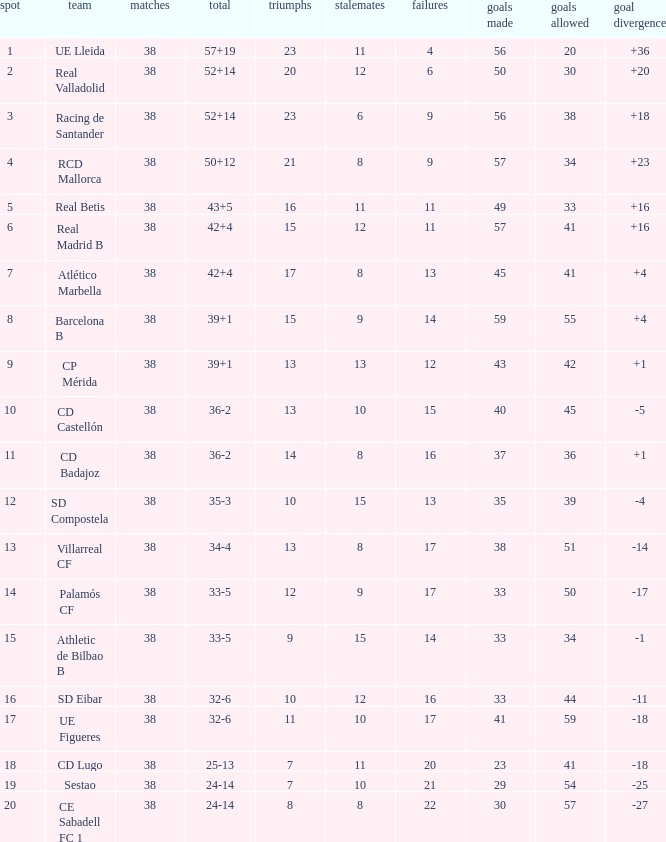What is the average goal difference with 51 goals scored against and less than 17 losses? None. 